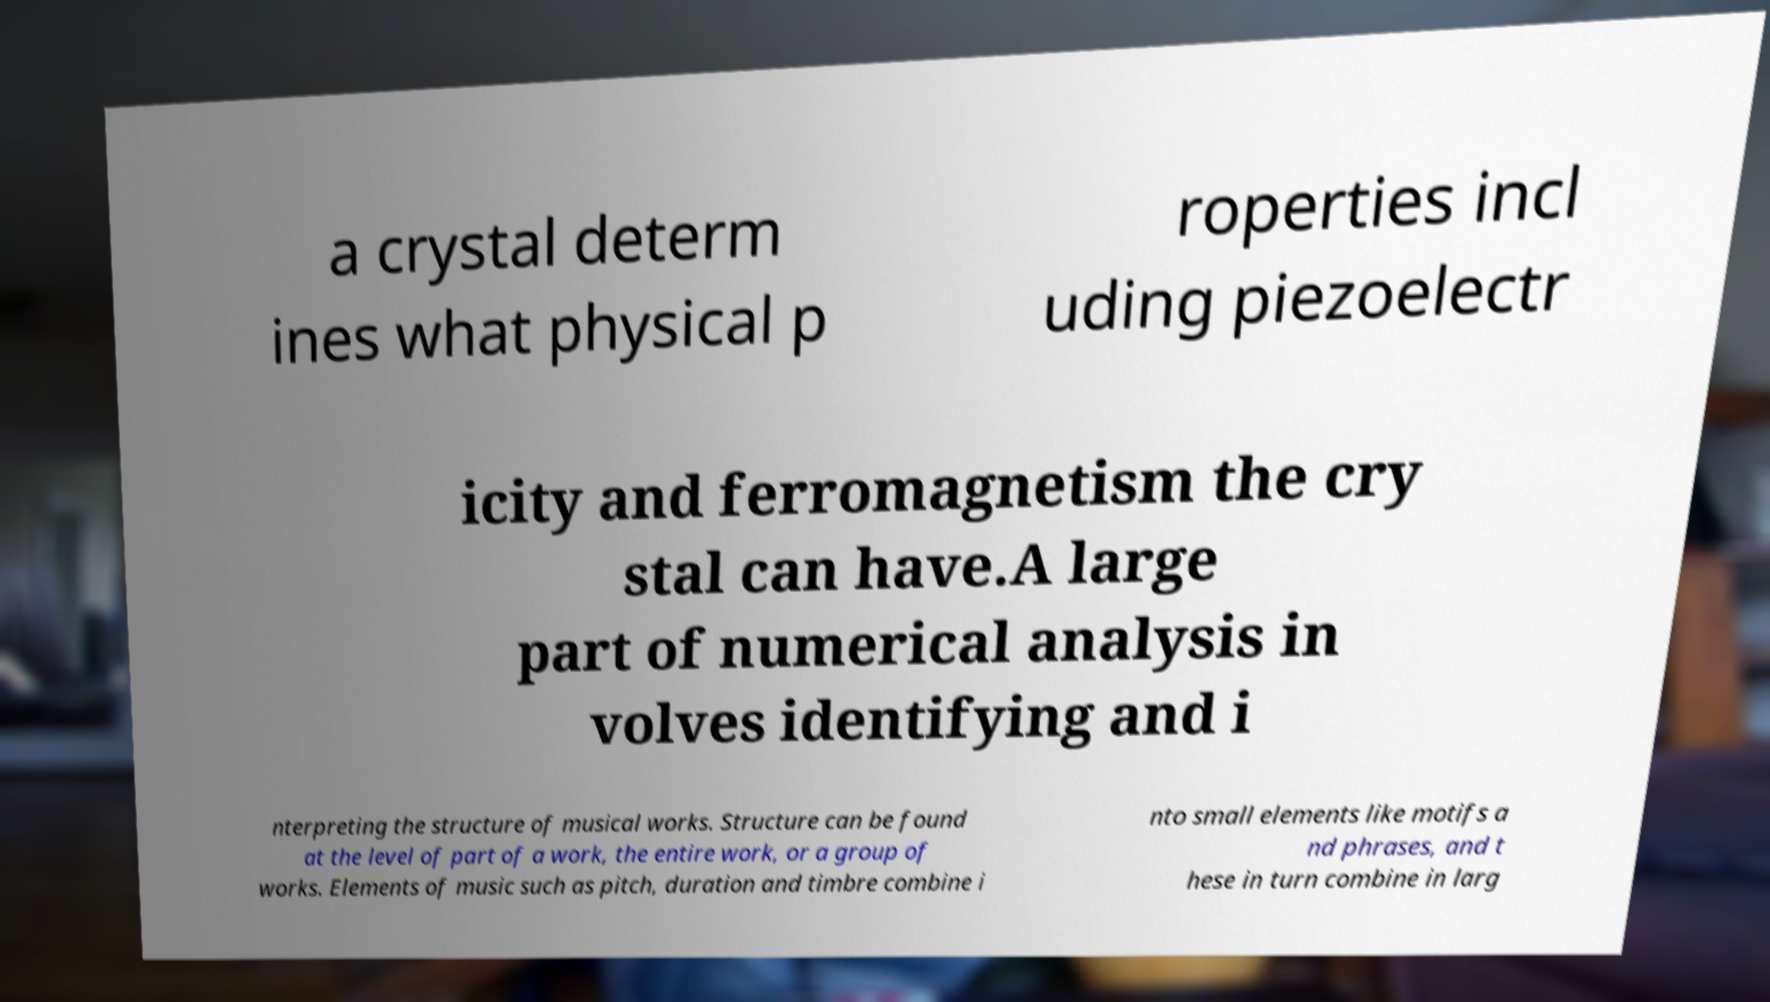Could you assist in decoding the text presented in this image and type it out clearly? a crystal determ ines what physical p roperties incl uding piezoelectr icity and ferromagnetism the cry stal can have.A large part of numerical analysis in volves identifying and i nterpreting the structure of musical works. Structure can be found at the level of part of a work, the entire work, or a group of works. Elements of music such as pitch, duration and timbre combine i nto small elements like motifs a nd phrases, and t hese in turn combine in larg 